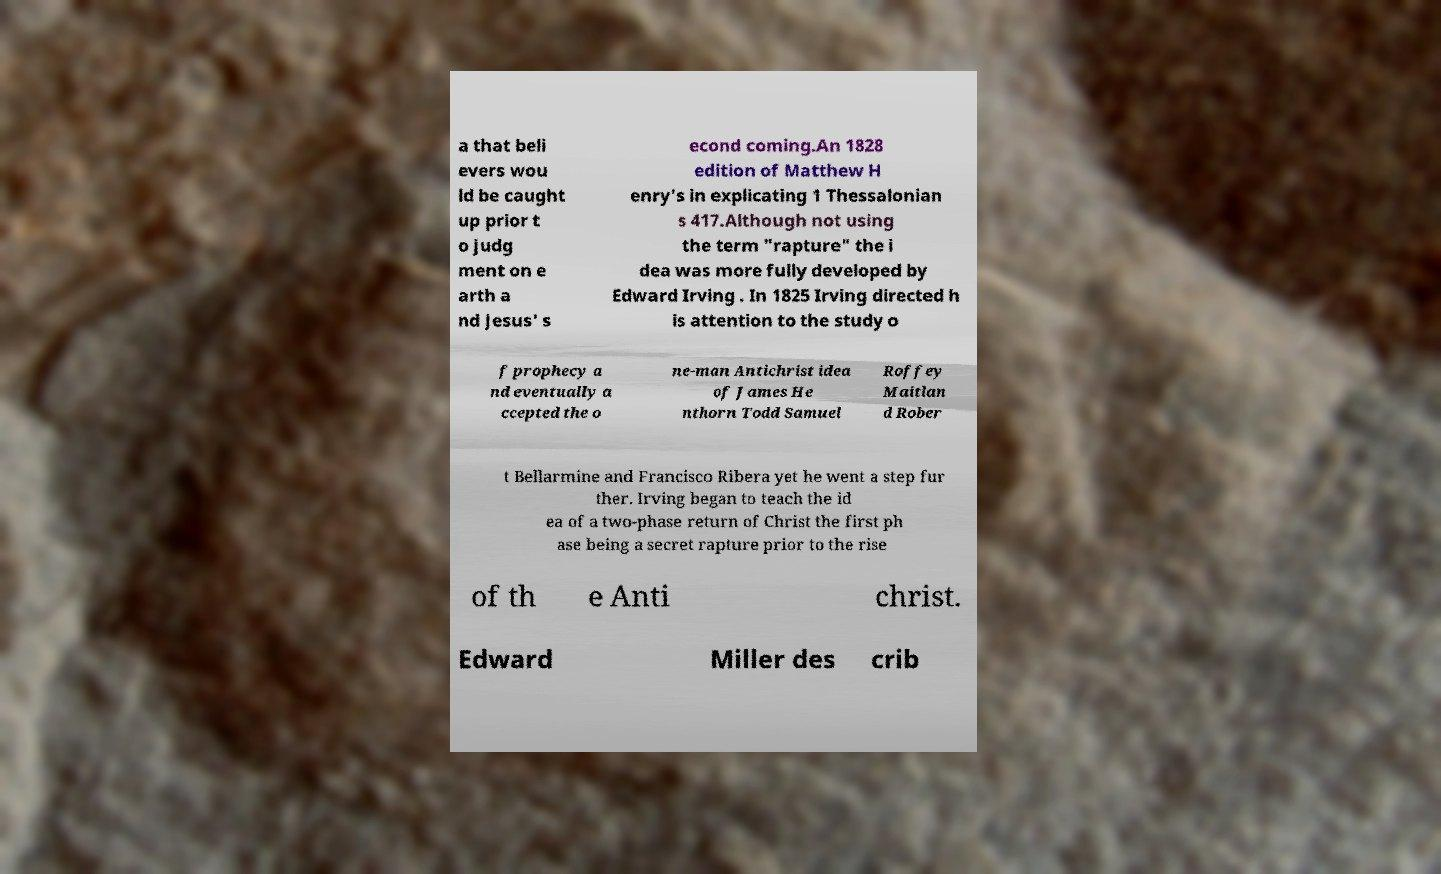Please identify and transcribe the text found in this image. a that beli evers wou ld be caught up prior t o judg ment on e arth a nd Jesus' s econd coming.An 1828 edition of Matthew H enry's in explicating 1 Thessalonian s 417.Although not using the term "rapture" the i dea was more fully developed by Edward Irving . In 1825 Irving directed h is attention to the study o f prophecy a nd eventually a ccepted the o ne-man Antichrist idea of James He nthorn Todd Samuel Roffey Maitlan d Rober t Bellarmine and Francisco Ribera yet he went a step fur ther. Irving began to teach the id ea of a two-phase return of Christ the first ph ase being a secret rapture prior to the rise of th e Anti christ. Edward Miller des crib 